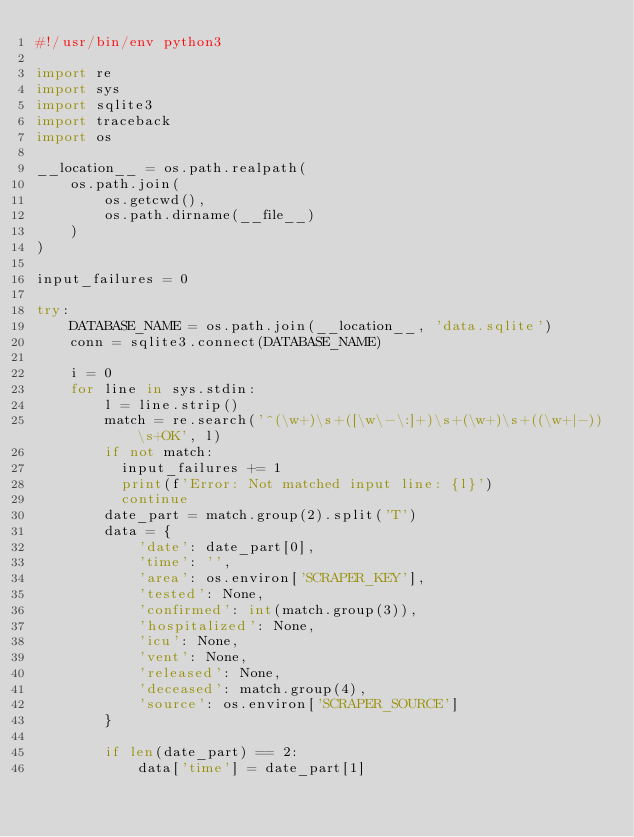<code> <loc_0><loc_0><loc_500><loc_500><_Python_>#!/usr/bin/env python3

import re
import sys
import sqlite3
import traceback
import os

__location__ = os.path.realpath(
    os.path.join(
        os.getcwd(),
        os.path.dirname(__file__)
    )
)

input_failures = 0

try:
    DATABASE_NAME = os.path.join(__location__, 'data.sqlite')
    conn = sqlite3.connect(DATABASE_NAME)

    i = 0
    for line in sys.stdin:
        l = line.strip()
        match = re.search('^(\w+)\s+([\w\-\:]+)\s+(\w+)\s+((\w+|-))\s+OK', l)
        if not match:
          input_failures += 1
          print(f'Error: Not matched input line: {l}')
          continue
        date_part = match.group(2).split('T')
        data = {
            'date': date_part[0],
            'time': '',
            'area': os.environ['SCRAPER_KEY'],
            'tested': None,
            'confirmed': int(match.group(3)),
            'hospitalized': None,
            'icu': None,
            'vent': None,
            'released': None,
            'deceased': match.group(4),
            'source': os.environ['SCRAPER_SOURCE']
        }

        if len(date_part) == 2:
            data['time'] = date_part[1]
</code> 